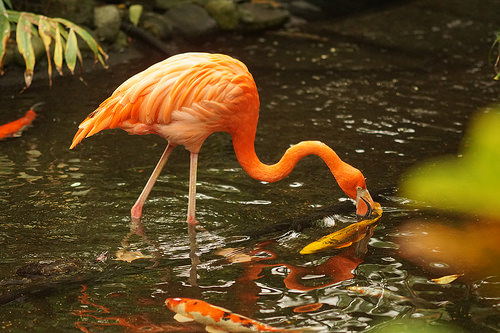<image>
Is there a flamingo above the water? Yes. The flamingo is positioned above the water in the vertical space, higher up in the scene. 